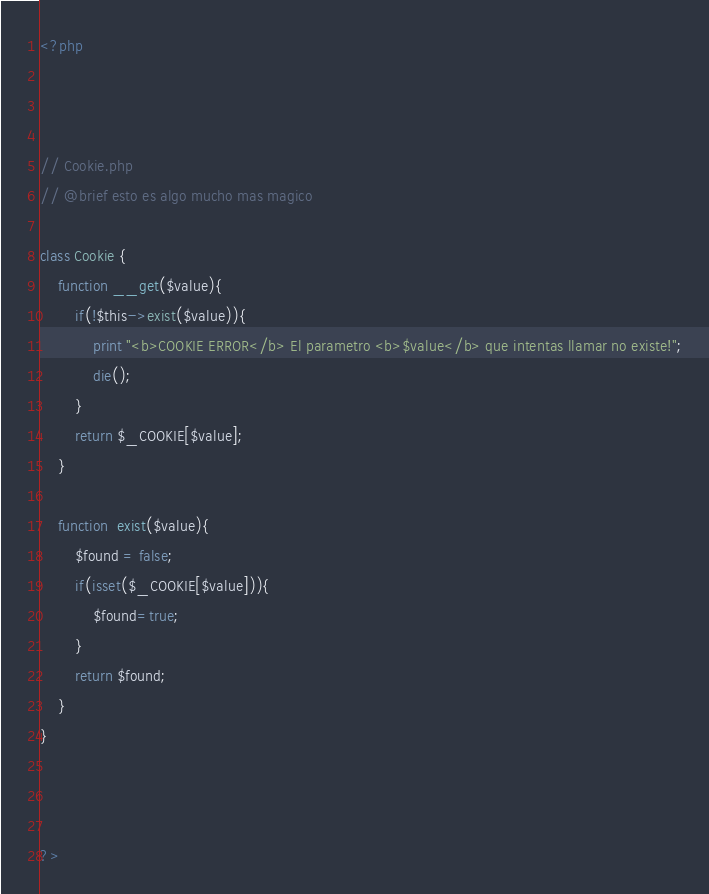<code> <loc_0><loc_0><loc_500><loc_500><_PHP_><?php



// Cookie.php
// @brief esto es algo mucho mas magico

class Cookie {
	function __get($value){
		if(!$this->exist($value)){
			print "<b>COOKIE ERROR</b> El parametro <b>$value</b> que intentas llamar no existe!";
			die();
		}
		return $_COOKIE[$value];
	}

	function  exist($value){
		$found = false;
		if(isset($_COOKIE[$value])){
			$found=true;
		}
		return $found;
	}
}



?></code> 